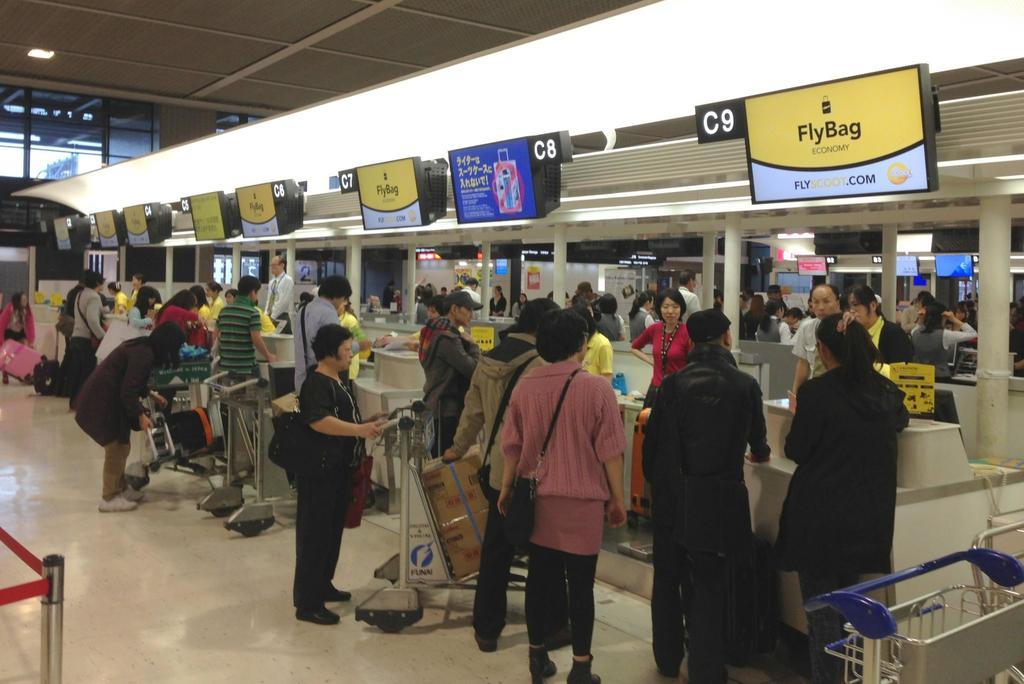How many people can be seen in the image? There are many people in the image. What objects are present to help transport luggage? Luggage carts are in the image to help transport luggage. Can you describe the luggage in the image? There is luggage in the image, but its specific appearance cannot be determined from the facts. What type of signs are visible in the image? There are boards with text and numbers in the image. What can be seen providing illumination in the image? There are lights in the image. What architectural features are present in the image? There are pillars in the image. Can you see any grass growing in the image? There is no grass visible in the image. Who is the friend standing next to the person in the image? The facts provided do not mention any specific individuals or friends in the image. 